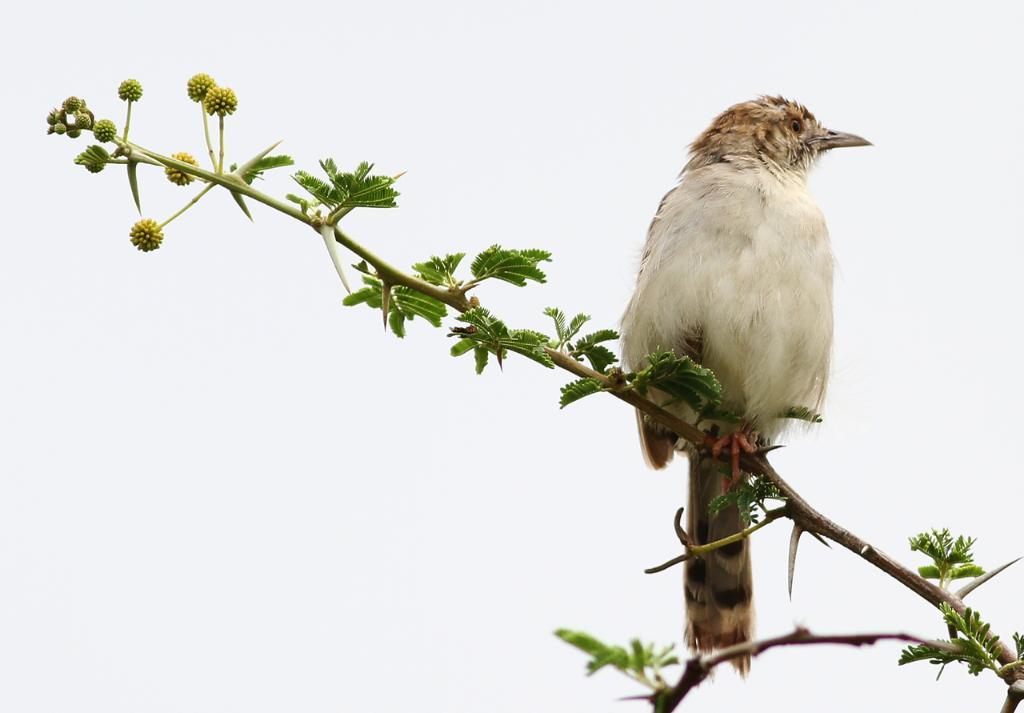What type of animal is in the image? There is a bird in the image. Where is the bird located? The bird is on a plant stem. What color is the background of the image? The background of the image is white. How many oranges are hanging from the bird's beak in the image? There are no oranges present in the image, and the bird's beak is not visible. 